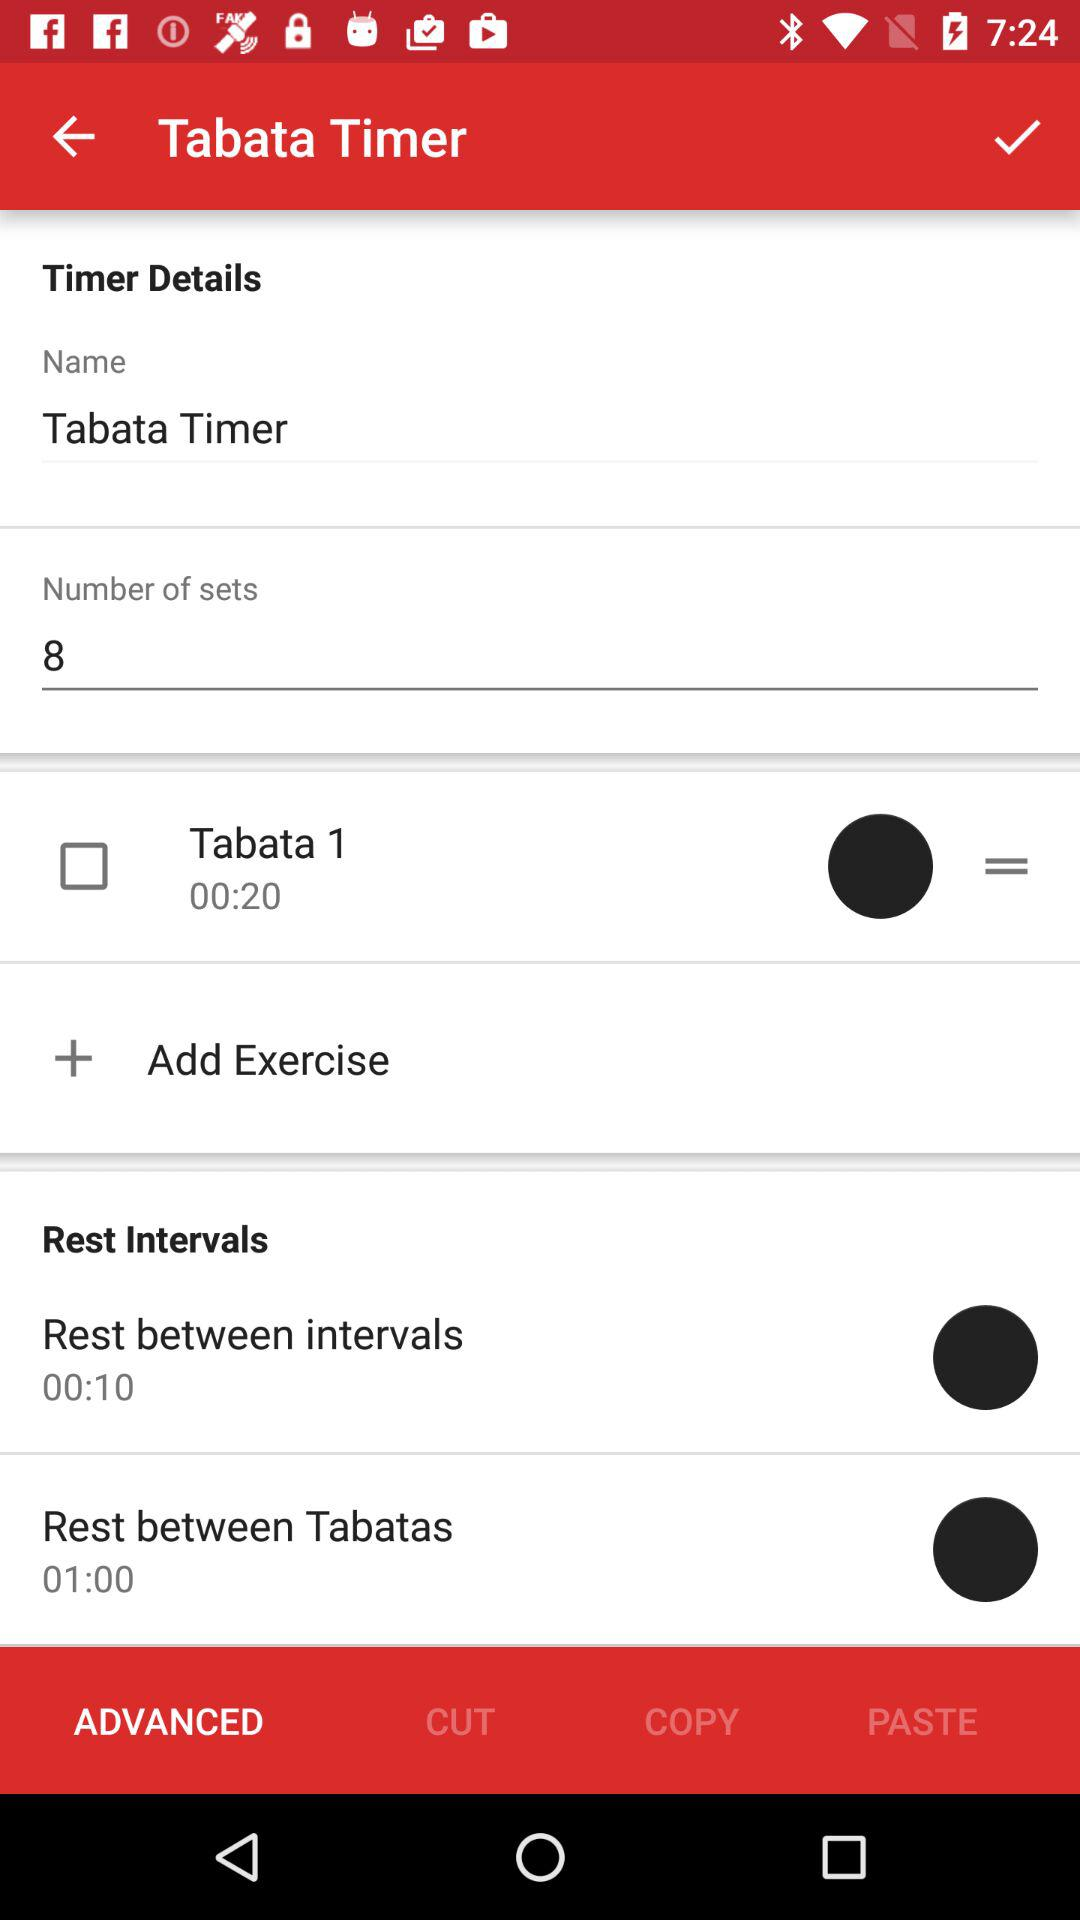How many calories does "Tabata" burn?
When the provided information is insufficient, respond with <no answer>. <no answer> 